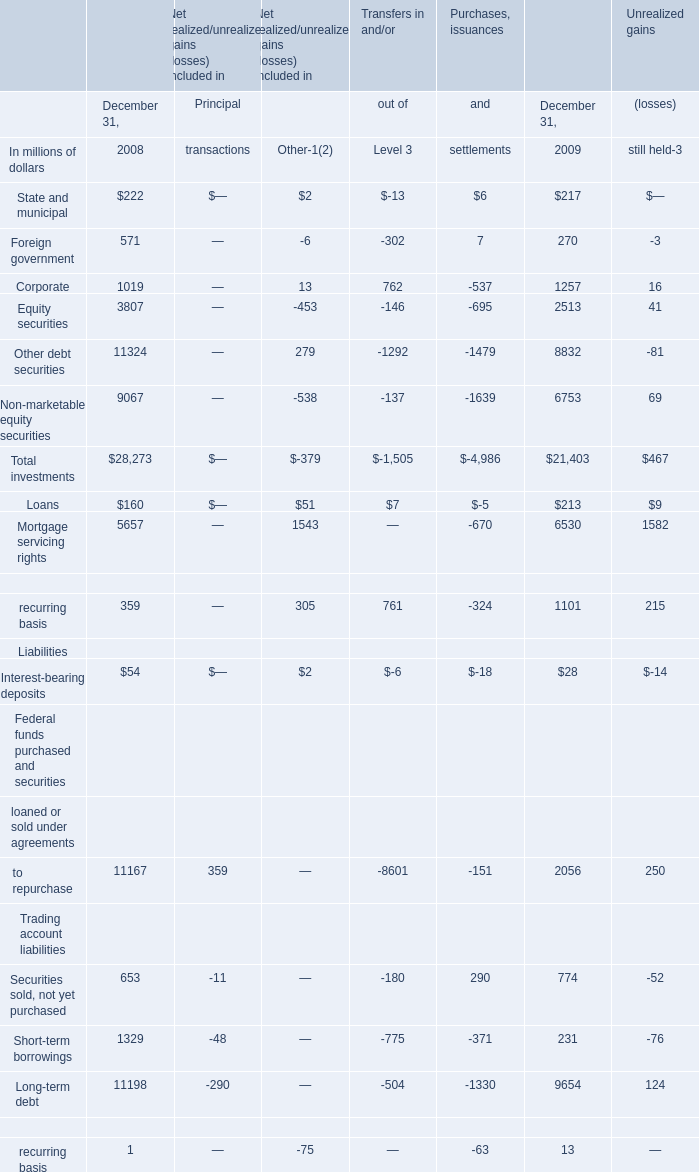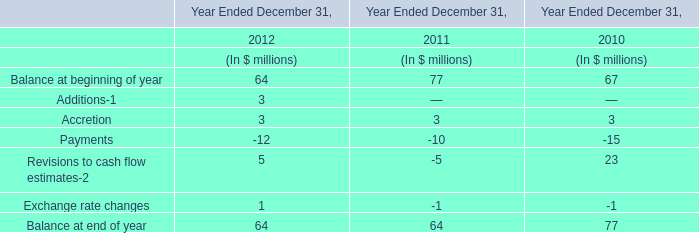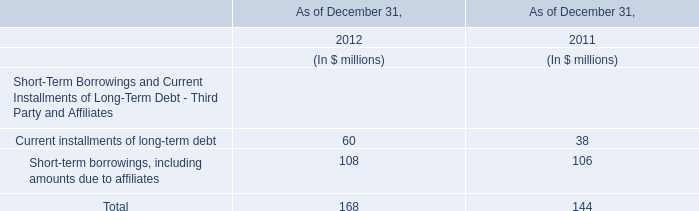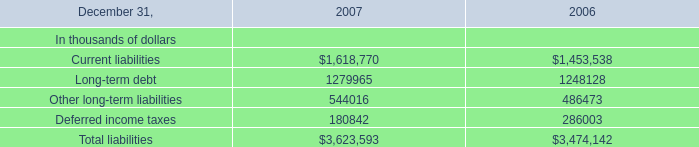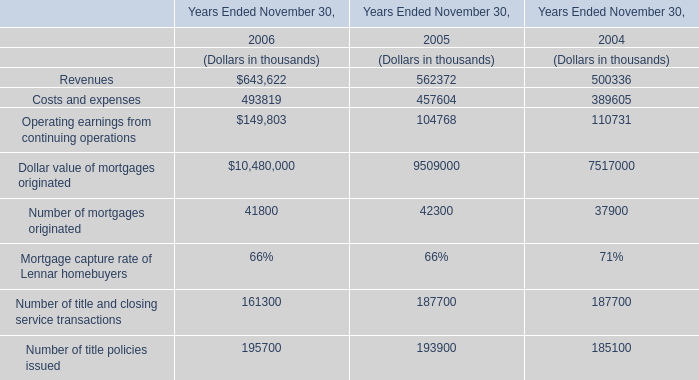What is the growing rate of Other long-term liabilities in the years with the least Number of title and closing service transactions? 
Computations: ((544016 - 486473) / 486473)
Answer: 0.11829. 